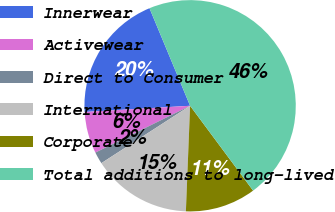Convert chart to OTSL. <chart><loc_0><loc_0><loc_500><loc_500><pie_chart><fcel>Innerwear<fcel>Activewear<fcel>Direct to Consumer<fcel>International<fcel>Corporate<fcel>Total additions to long-lived<nl><fcel>19.66%<fcel>6.37%<fcel>1.83%<fcel>15.23%<fcel>10.8%<fcel>46.12%<nl></chart> 